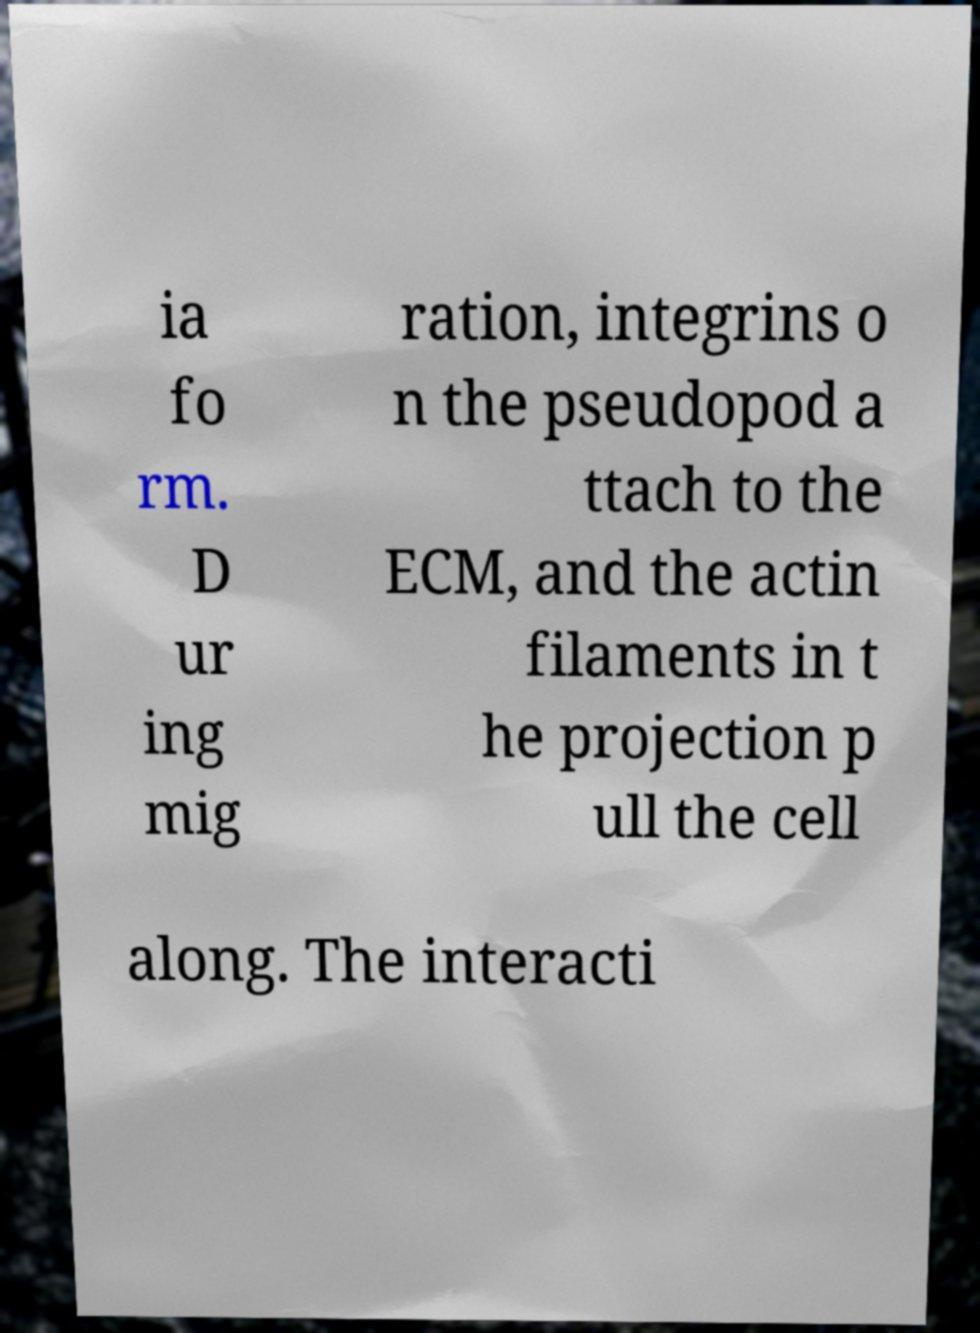Could you extract and type out the text from this image? ia fo rm. D ur ing mig ration, integrins o n the pseudopod a ttach to the ECM, and the actin filaments in t he projection p ull the cell along. The interacti 